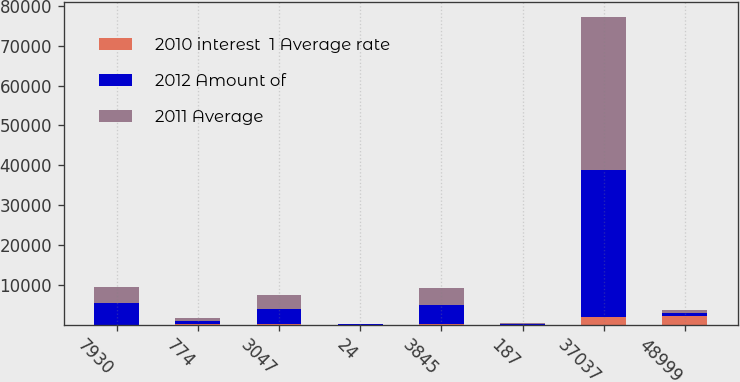Convert chart. <chart><loc_0><loc_0><loc_500><loc_500><stacked_bar_chart><ecel><fcel>7930<fcel>774<fcel>3047<fcel>24<fcel>3845<fcel>187<fcel>37037<fcel>48999<nl><fcel>2010 interest  1 Average rate<fcel>21.1<fcel>42.3<fcel>94.2<fcel>0.7<fcel>137.2<fcel>6.6<fcel>1892<fcel>2056.9<nl><fcel>2012 Amount of<fcel>5356<fcel>818<fcel>3895<fcel>58<fcel>4771<fcel>146<fcel>36897<fcel>842<nl><fcel>2011 Average<fcel>4085<fcel>866<fcel>3416<fcel>61<fcel>4343<fcel>187<fcel>38326<fcel>842<nl></chart> 